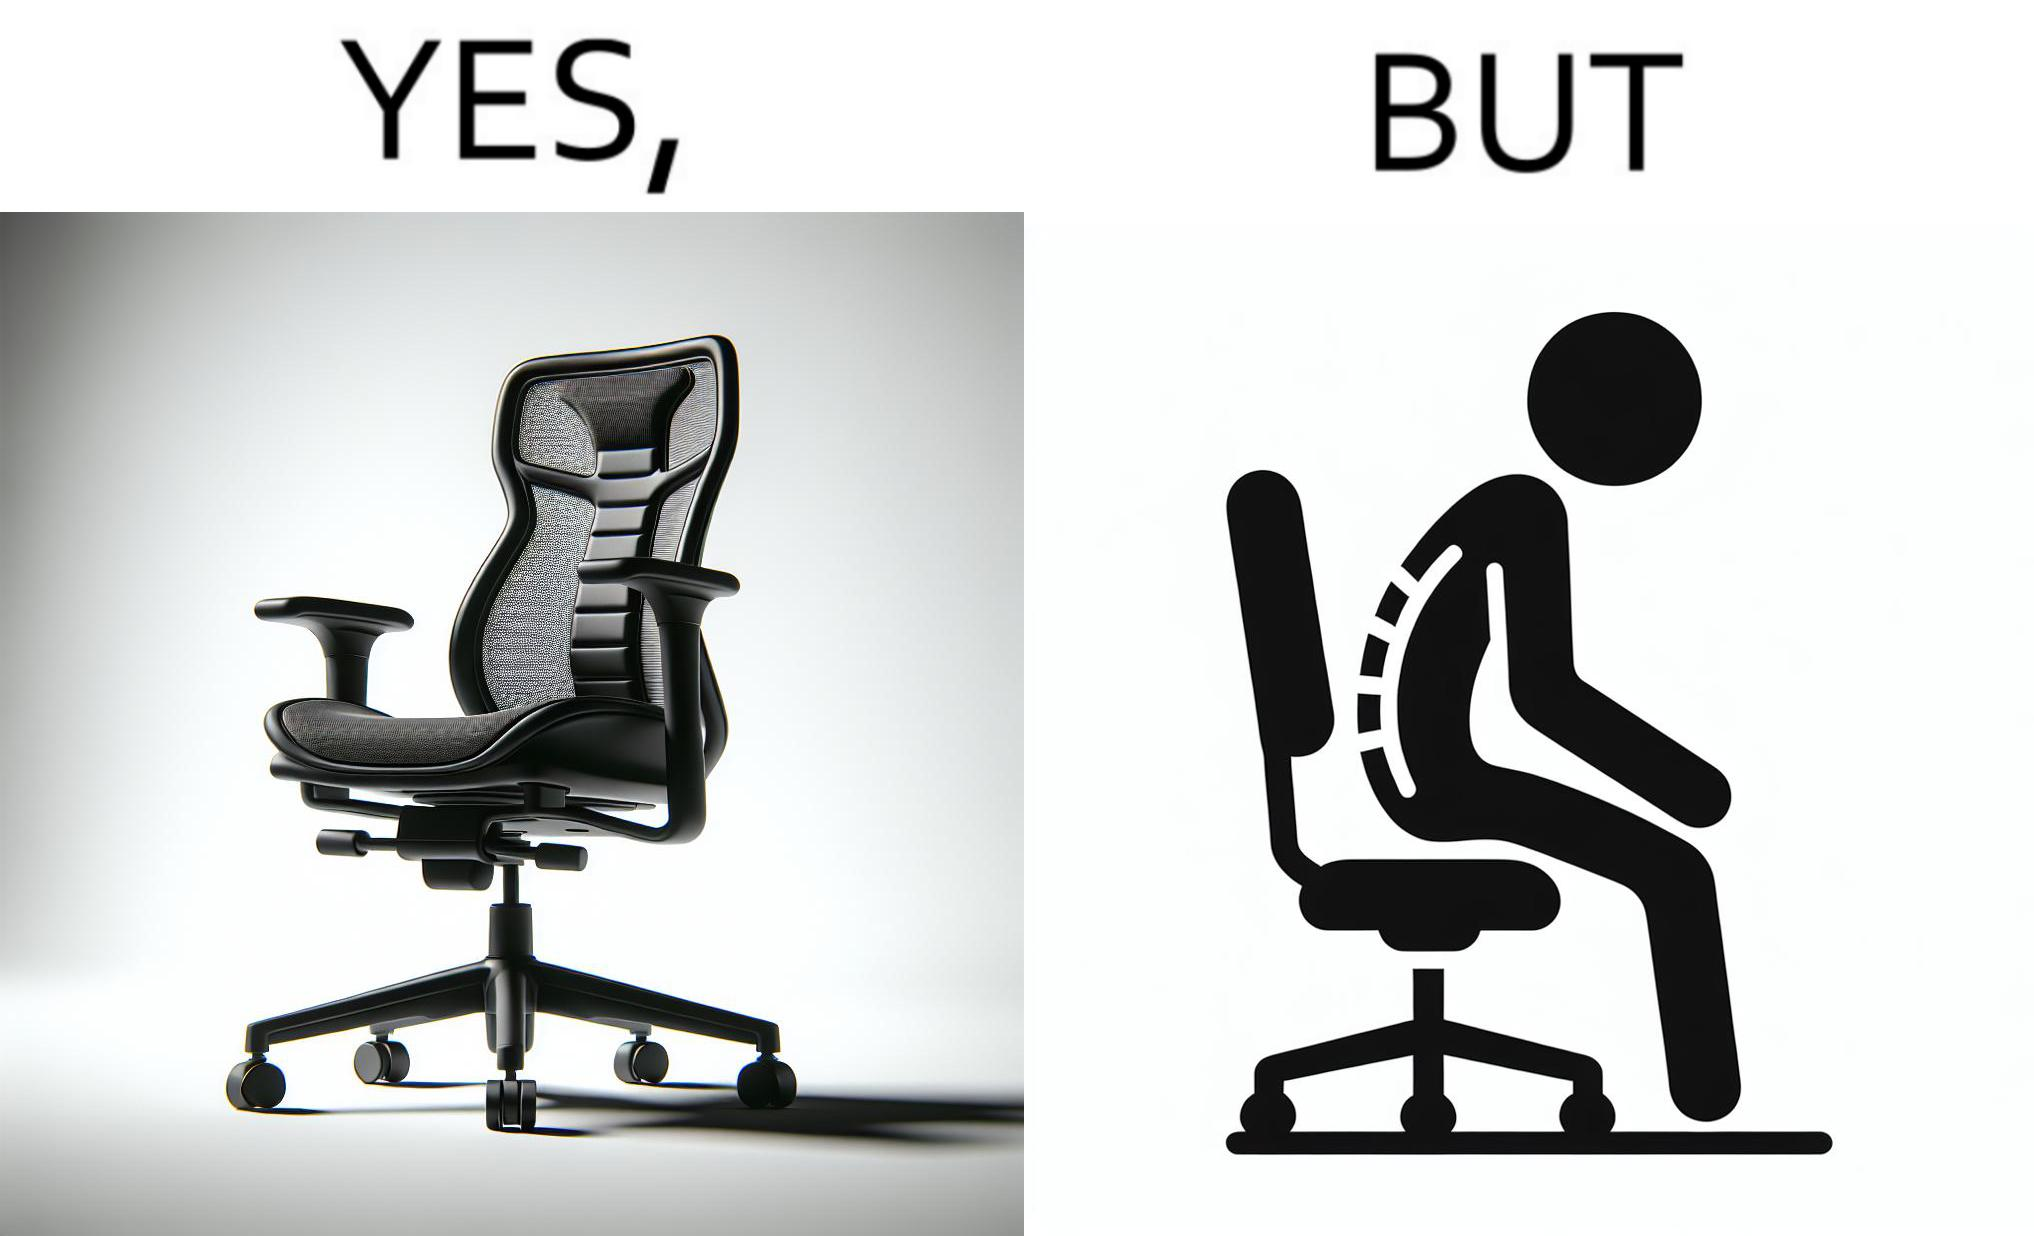Compare the left and right sides of this image. In the left part of the image: an ergonomic chair. In the right part of the image: a person sitting on a ergonomic chair with a bent spine. 